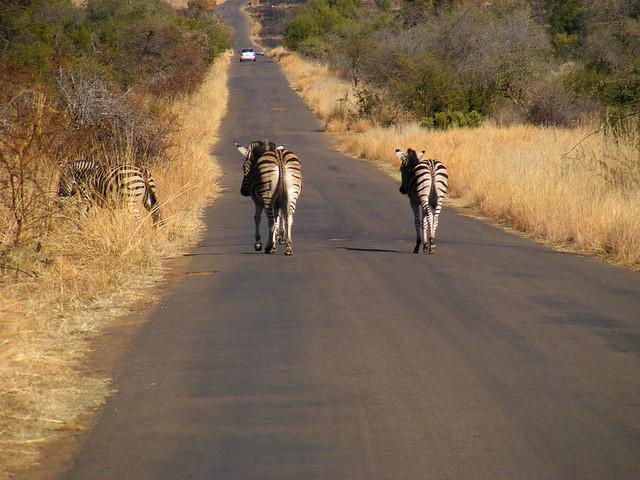What are the animals showing to the camera?
From the following set of four choices, select the accurate answer to respond to the question.
Options: Tusks, backside, antlers, horns. Backside. 